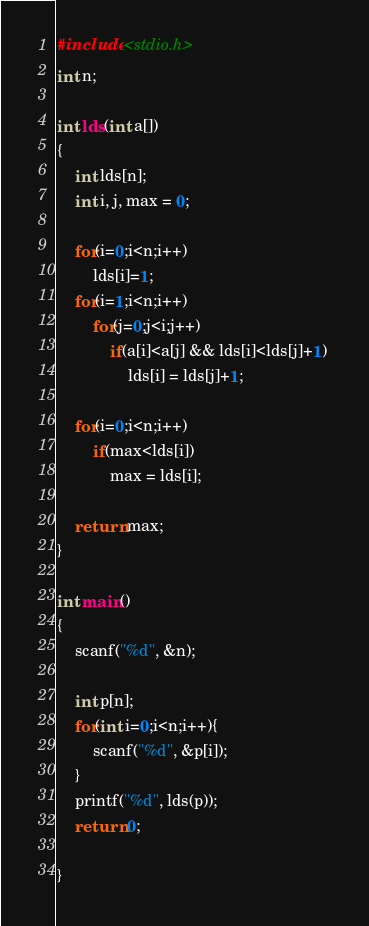Convert code to text. <code><loc_0><loc_0><loc_500><loc_500><_C_>#include <stdio.h>
int n;

int lds(int a[]) 
{ 
    int lds[n]; 
    int i, j, max = 0; 
  
    for(i=0;i<n;i++) 
        lds[i]=1; 
  	for(i=1;i<n;i++) 
        for(j=0;j<i;j++) 
            if(a[i]<a[j] && lds[i]<lds[j]+1) 
                lds[i] = lds[j]+1; 

    for(i=0;i<n;i++) 
        if(max<lds[i]) 
            max = lds[i]; 
  
    return max; 
} 

int main() 
{ 
    scanf("%d", &n);
    
    int p[n];
    for(int i=0;i<n;i++){
        scanf("%d", &p[i]);
    }
  	printf("%d", lds(p));
    return 0;
    
}</code> 